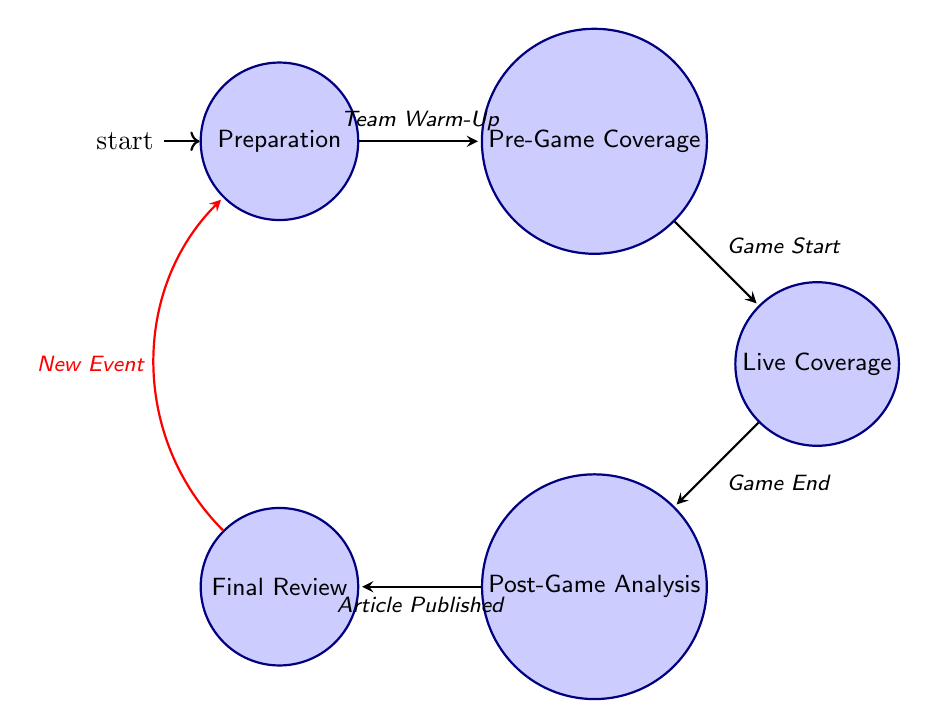What is the first state in the workflow? The first state in the workflow, as indicated in the diagram, is "Preparation". It is labeled as the initial state, showing that it's the starting point of the journalist's workflow.
Answer: Preparation How many states are there in total in the diagram? Counting the states in the diagram, we have five distinct states: Preparation, Pre-Game Coverage, Live Coverage, Post-Game Analysis, and Final Review. Therefore, the total number of states is five.
Answer: 5 What action is associated with the "Live Coverage" state? In the "Live Coverage" state, one of the listed actions is "Provide Live Commentary". This action represents a specific task the journalist performs while covering a game live.
Answer: Provide Live Commentary What triggers the transition from "Pre-Game Coverage" to "Live Coverage"? The transition from "Pre-Game Coverage" to "Live Coverage" is triggered by the event "Game Start". This indicates that the approach of the game commencing is what shifts the focus from pre-game activities to live reporting.
Answer: Game Start After which state does the transition to "Final Review" occur? The transition to "Final Review" occurs after the "Post-Game Analysis" state, specifically when the trigger event "Article Published" is reached. This shows a clear progression from analyzing the game results to reviewing the published content.
Answer: Post-Game Analysis What happens when a new event is introduced after the "Final Review"? When a new event is introduced after the "Final Review", it triggers a transition back to the "Preparation" state. This signifies that once the current event's coverage is concluded, the journalist begins preparing for the next event.
Answer: Preparation How many actions are associated with the "Post-Game Analysis" state? The "Post-Game Analysis" state includes four actions: "Attend Post-Game Press Conference", "Analyze Game Data", "Write Post-Game Article", and "Upload Final Content". Therefore, there are four actions associated with this state.
Answer: 4 Which state does the "Take Real-Time Notes" action belong to? The action "Take Real-Time Notes" belongs to the "Live Coverage" state. This means that during live coverage, noting events as they happen is a crucial task for the journalist.
Answer: Live Coverage What is the transition trigger from "Preparation" to "Pre-Game Coverage"? The transition from "Preparation" to "Pre-Game Coverage" is triggered by "Team Warm-Up". This indicates that once the teams start warming up, the focus shifts towards pre-game activities.
Answer: Team Warm-Up 